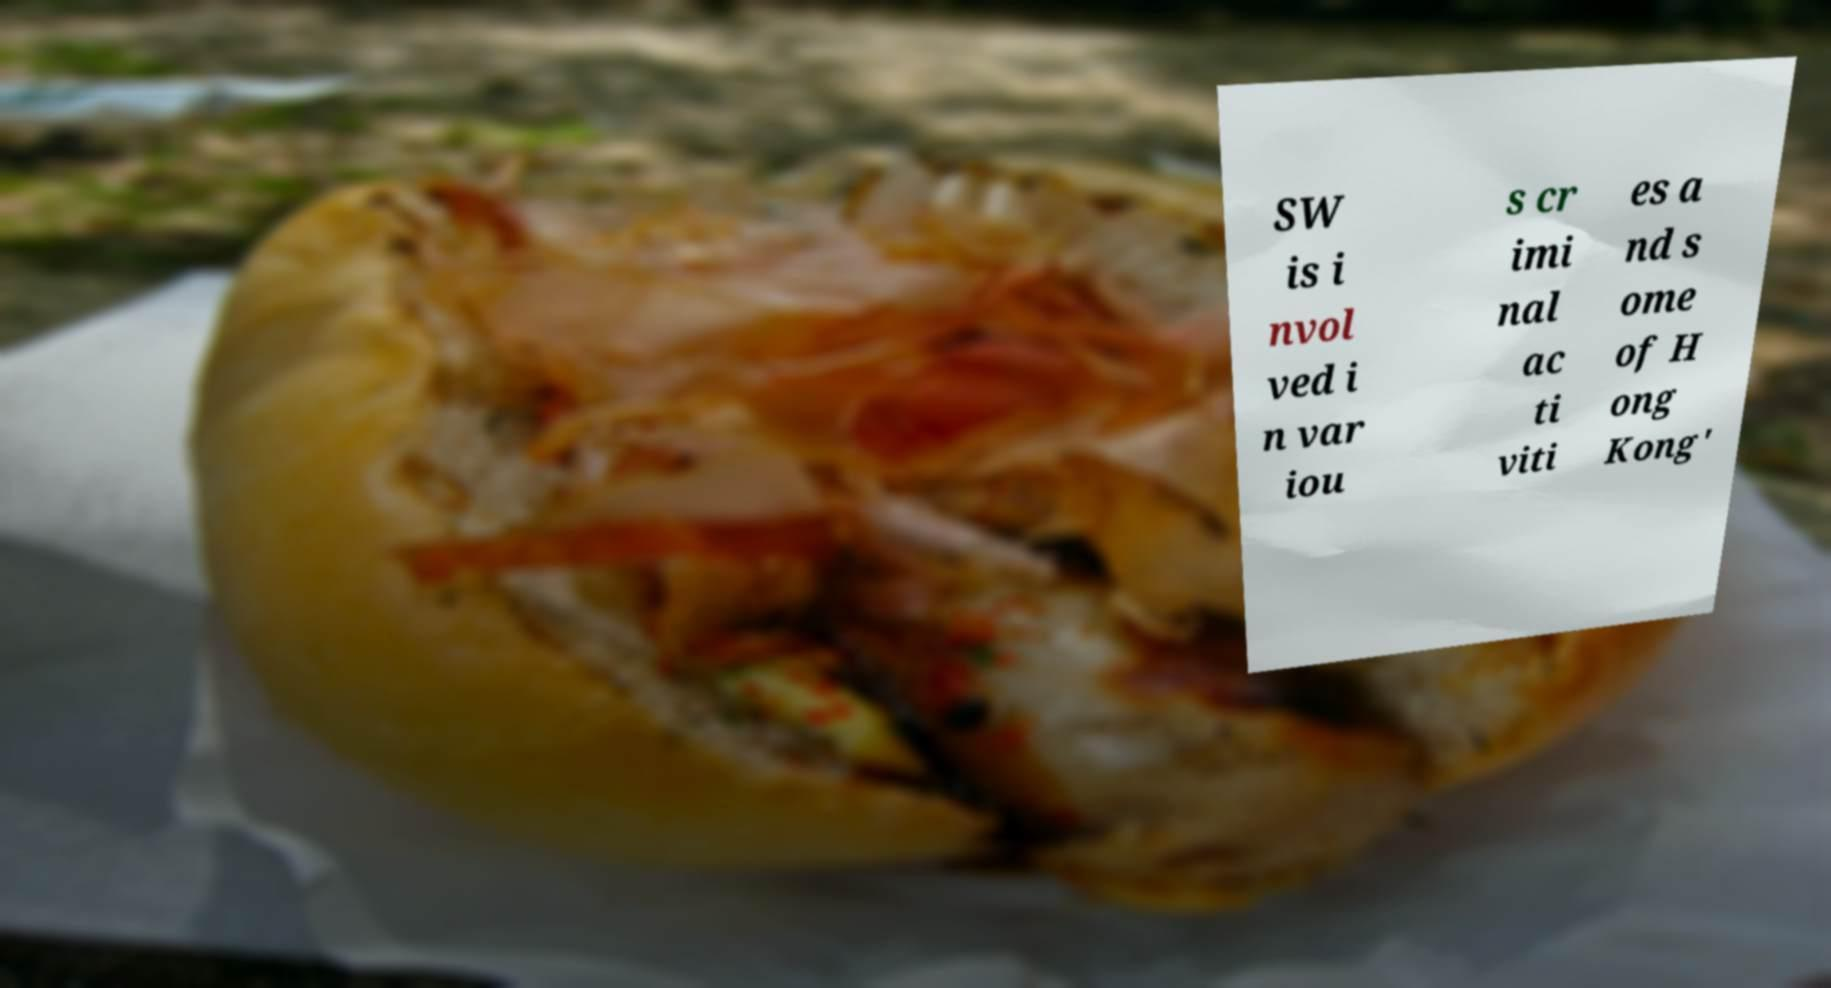What messages or text are displayed in this image? I need them in a readable, typed format. SW is i nvol ved i n var iou s cr imi nal ac ti viti es a nd s ome of H ong Kong' 